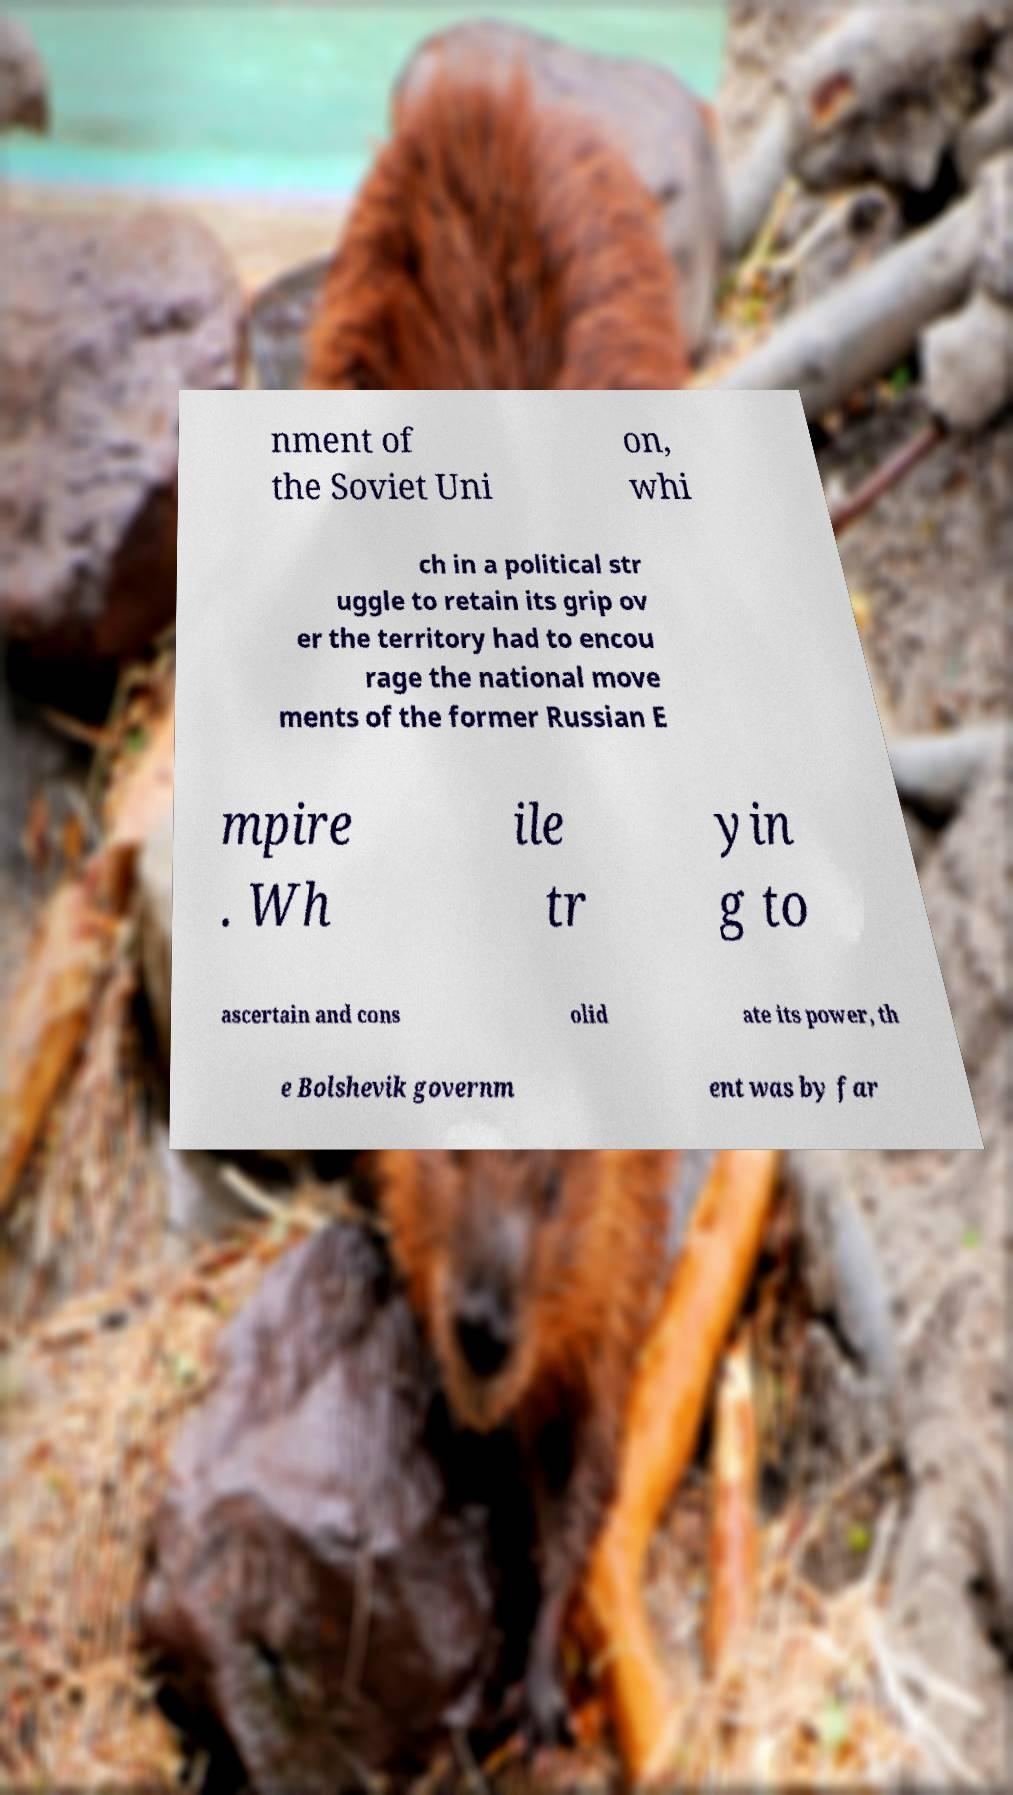I need the written content from this picture converted into text. Can you do that? nment of the Soviet Uni on, whi ch in a political str uggle to retain its grip ov er the territory had to encou rage the national move ments of the former Russian E mpire . Wh ile tr yin g to ascertain and cons olid ate its power, th e Bolshevik governm ent was by far 